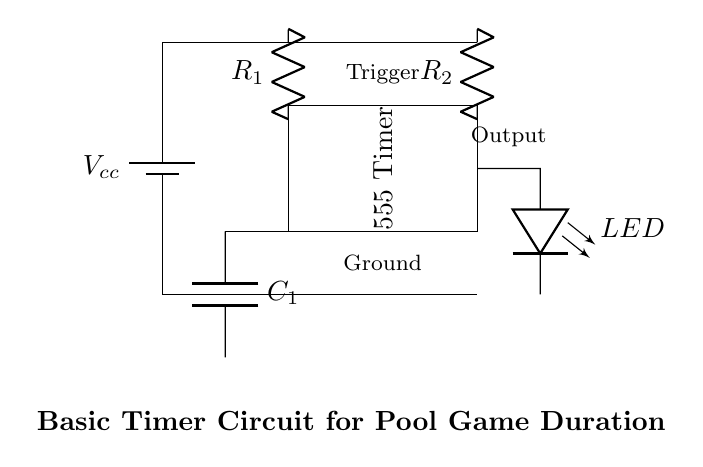What is the supply voltage for this timer circuit? The diagram shows a battery labeled Vcc connected to power the circuit, indicating that the supply voltage is denoted as Vcc.
Answer: Vcc What type of components are used in this timer circuit? The circuit includes a timer IC, resistors, a capacitor, and an LED. These components work together to create a functioning timer.
Answer: Timer IC, resistors, capacitor, LED What is the purpose of the capacitor in this circuit? The capacitor helps determine the timing interval for the 555 timer. It charges and discharges to set the timing duration, controlling the LED's on/off cycle.
Answer: Timing interval How many resistors are present in the circuit and what are their labels? There are two resistors in the circuit, labeled R1 and R2, which are connected in series with the 555 timer to influence its timing characteristics.
Answer: Two, R1 and R2 If the LED is on, what does that indicate about the timer state? If the LED is on, it indicates that the output of the timer is high, meaning the timing period is active or the set time duration has not yet expired.
Answer: Output is high What happens to the circuit output if the capacitor is removed? Removing the capacitor would prevent the timer from functioning properly, as there would be no way to set the timing interval needed for the LED control.
Answer: Timer fails 